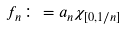<formula> <loc_0><loc_0><loc_500><loc_500>f _ { n } \colon = a _ { n } \chi _ { [ 0 , 1 / n ] }</formula> 